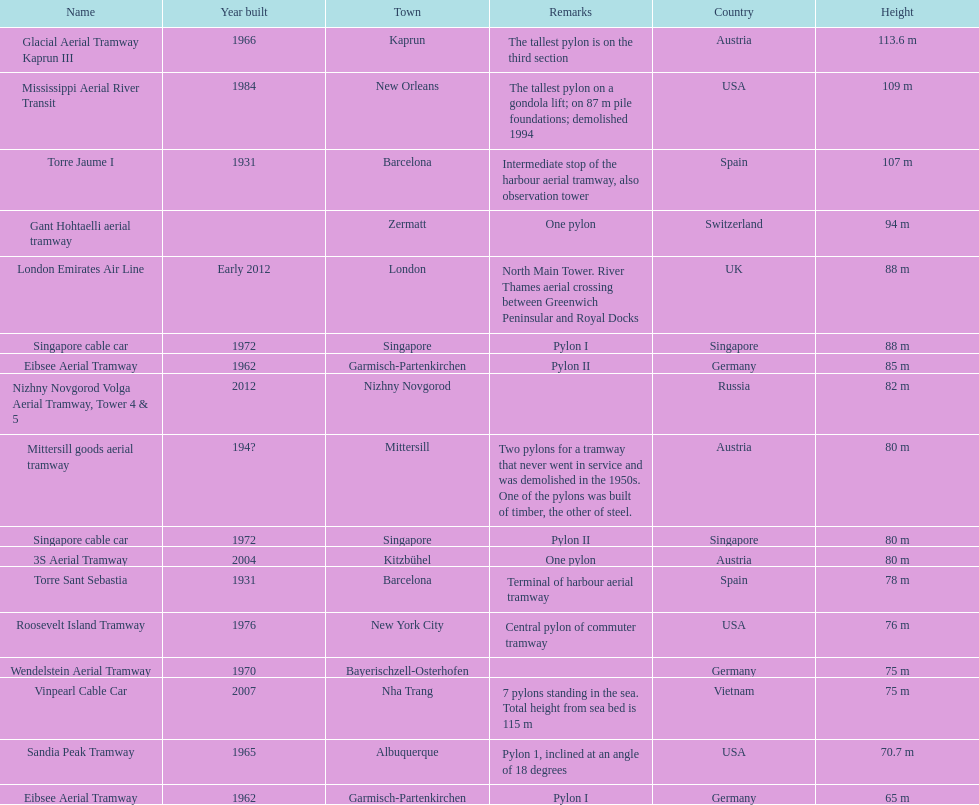Which pylon is the least tall? Eibsee Aerial Tramway. Could you parse the entire table? {'header': ['Name', 'Year built', 'Town', 'Remarks', 'Country', 'Height'], 'rows': [['Glacial Aerial Tramway Kaprun III', '1966', 'Kaprun', 'The tallest pylon is on the third section', 'Austria', '113.6 m'], ['Mississippi Aerial River Transit', '1984', 'New Orleans', 'The tallest pylon on a gondola lift; on 87 m pile foundations; demolished 1994', 'USA', '109 m'], ['Torre Jaume I', '1931', 'Barcelona', 'Intermediate stop of the harbour aerial tramway, also observation tower', 'Spain', '107 m'], ['Gant Hohtaelli aerial tramway', '', 'Zermatt', 'One pylon', 'Switzerland', '94 m'], ['London Emirates Air Line', 'Early 2012', 'London', 'North Main Tower. River Thames aerial crossing between Greenwich Peninsular and Royal Docks', 'UK', '88 m'], ['Singapore cable car', '1972', 'Singapore', 'Pylon I', 'Singapore', '88 m'], ['Eibsee Aerial Tramway', '1962', 'Garmisch-Partenkirchen', 'Pylon II', 'Germany', '85 m'], ['Nizhny Novgorod Volga Aerial Tramway, Tower 4 & 5', '2012', 'Nizhny Novgorod', '', 'Russia', '82 m'], ['Mittersill goods aerial tramway', '194?', 'Mittersill', 'Two pylons for a tramway that never went in service and was demolished in the 1950s. One of the pylons was built of timber, the other of steel.', 'Austria', '80 m'], ['Singapore cable car', '1972', 'Singapore', 'Pylon II', 'Singapore', '80 m'], ['3S Aerial Tramway', '2004', 'Kitzbühel', 'One pylon', 'Austria', '80 m'], ['Torre Sant Sebastia', '1931', 'Barcelona', 'Terminal of harbour aerial tramway', 'Spain', '78 m'], ['Roosevelt Island Tramway', '1976', 'New York City', 'Central pylon of commuter tramway', 'USA', '76 m'], ['Wendelstein Aerial Tramway', '1970', 'Bayerischzell-Osterhofen', '', 'Germany', '75 m'], ['Vinpearl Cable Car', '2007', 'Nha Trang', '7 pylons standing in the sea. Total height from sea bed is 115 m', 'Vietnam', '75 m'], ['Sandia Peak Tramway', '1965', 'Albuquerque', 'Pylon 1, inclined at an angle of 18 degrees', 'USA', '70.7 m'], ['Eibsee Aerial Tramway', '1962', 'Garmisch-Partenkirchen', 'Pylon I', 'Germany', '65 m']]} 